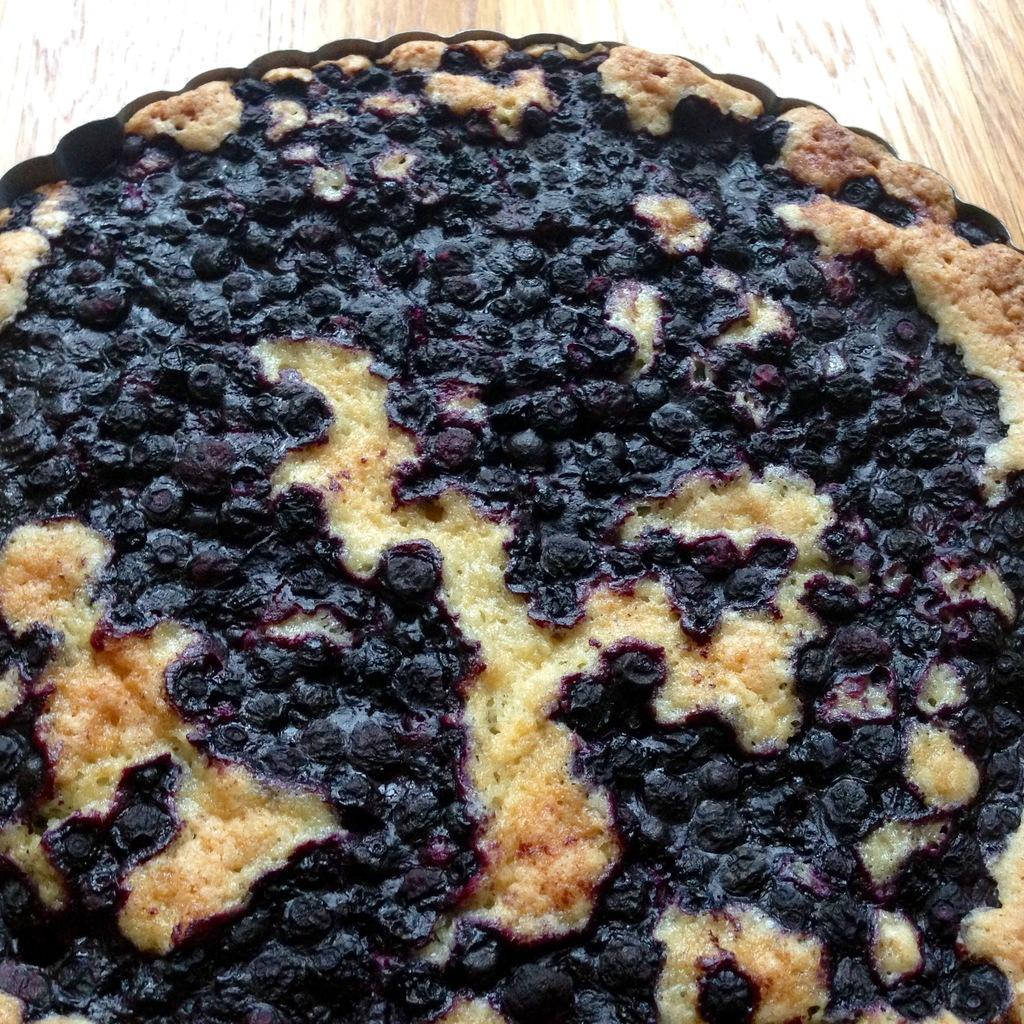What is the main food item visible in the image? There is a cake in the image. What is the primary piece of furniture in the image? There is a table in the image. What type of net can be seen surrounding the cake in the image? There is no net present in the image; it only features a cake and a table. 